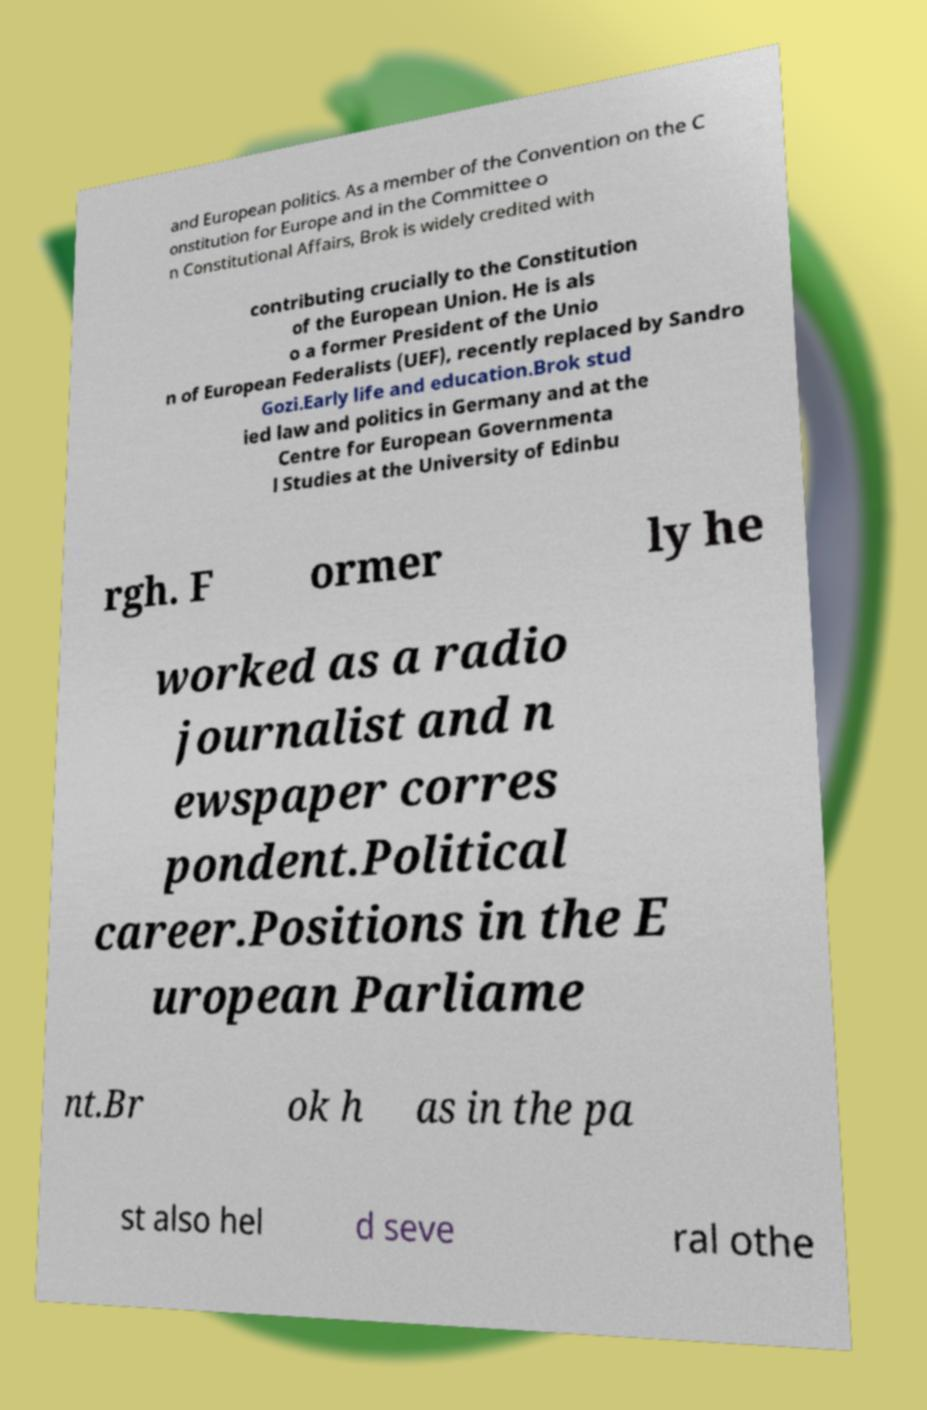Can you read and provide the text displayed in the image?This photo seems to have some interesting text. Can you extract and type it out for me? and European politics. As a member of the Convention on the C onstitution for Europe and in the Committee o n Constitutional Affairs, Brok is widely credited with contributing crucially to the Constitution of the European Union. He is als o a former President of the Unio n of European Federalists (UEF), recently replaced by Sandro Gozi.Early life and education.Brok stud ied law and politics in Germany and at the Centre for European Governmenta l Studies at the University of Edinbu rgh. F ormer ly he worked as a radio journalist and n ewspaper corres pondent.Political career.Positions in the E uropean Parliame nt.Br ok h as in the pa st also hel d seve ral othe 